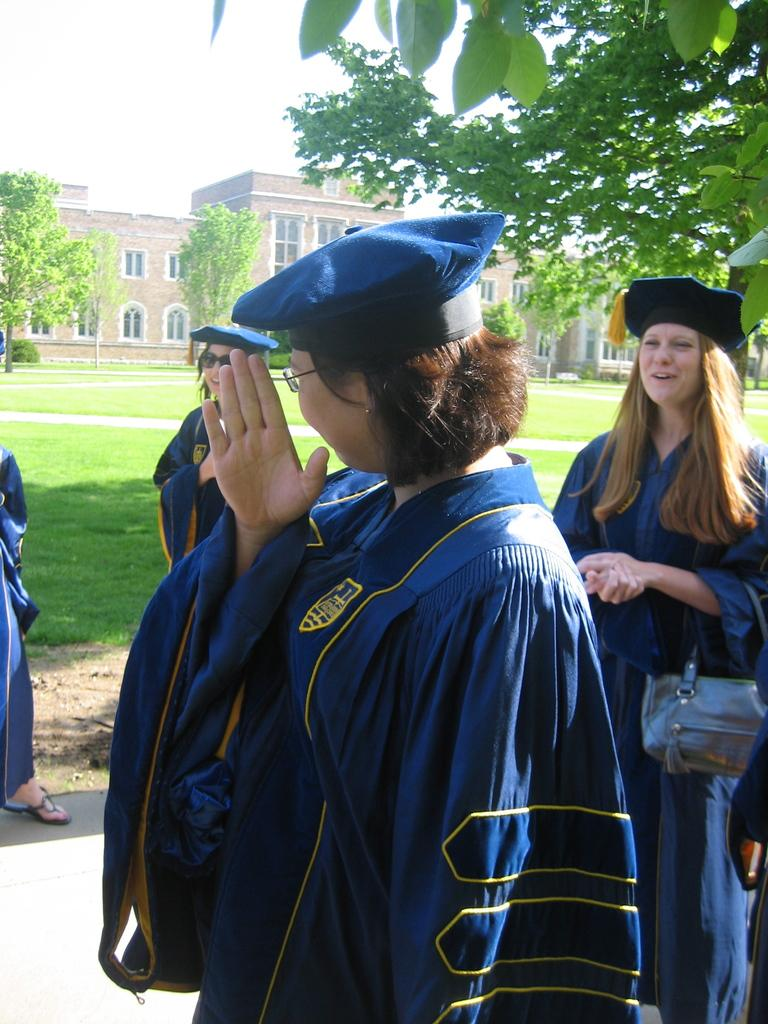What are the persons in the image wearing? The persons in the image are wearing clothes and caps. What can be seen in the middle of the image? There is a building and trees in the middle of the image. What is visible at the top of the image? The sky is visible at the top of the image. What type of quince is being used in the verse written on the building in the image? There is no quince or verse present in the image, and therefore no such activity can be observed. 